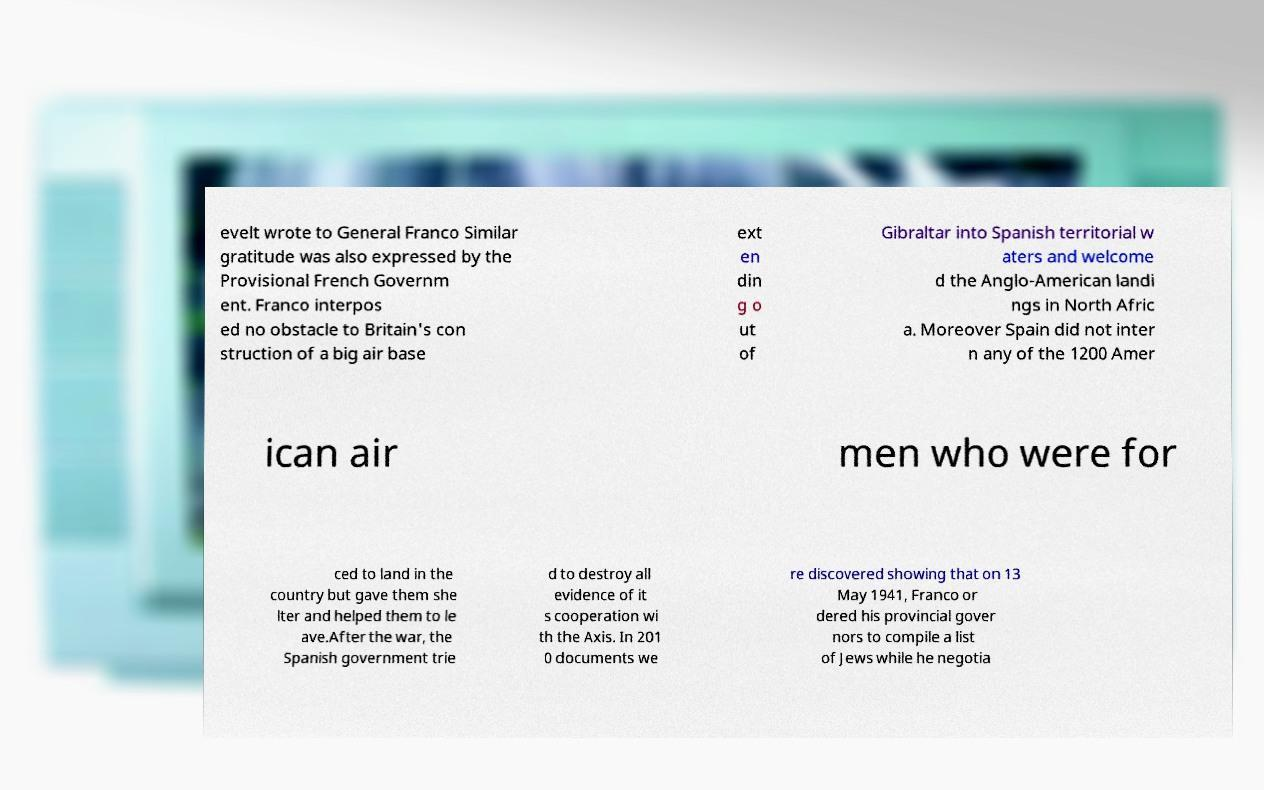Can you read and provide the text displayed in the image?This photo seems to have some interesting text. Can you extract and type it out for me? evelt wrote to General Franco Similar gratitude was also expressed by the Provisional French Governm ent. Franco interpos ed no obstacle to Britain's con struction of a big air base ext en din g o ut of Gibraltar into Spanish territorial w aters and welcome d the Anglo-American landi ngs in North Afric a. Moreover Spain did not inter n any of the 1200 Amer ican air men who were for ced to land in the country but gave them she lter and helped them to le ave.After the war, the Spanish government trie d to destroy all evidence of it s cooperation wi th the Axis. In 201 0 documents we re discovered showing that on 13 May 1941, Franco or dered his provincial gover nors to compile a list of Jews while he negotia 